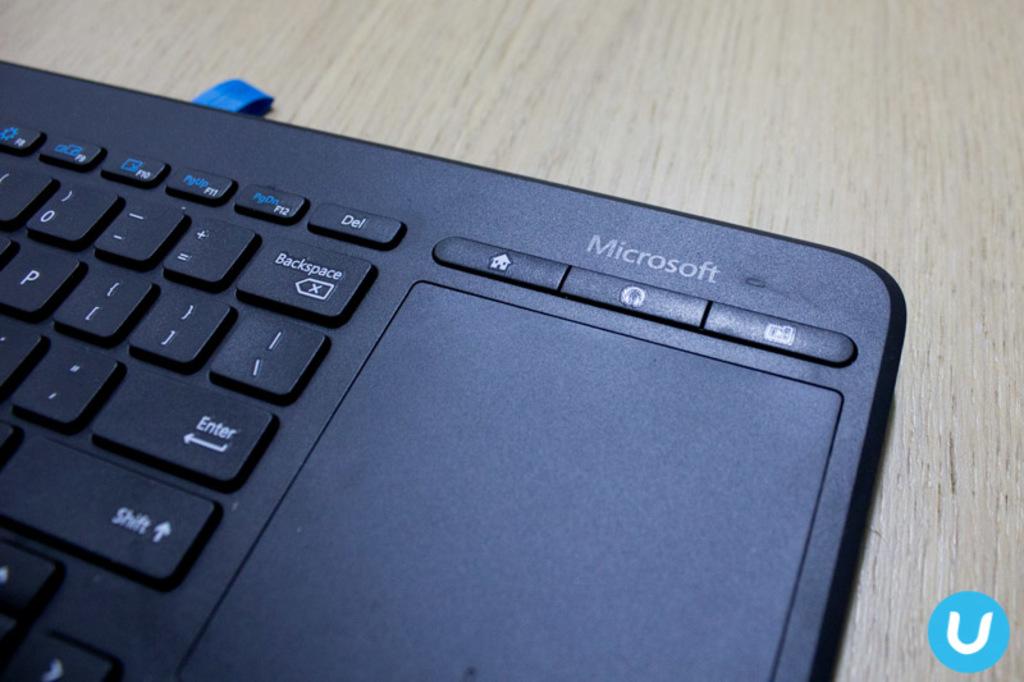What brand is the keyboard of?
Your response must be concise. Microsoft. What brand is the keyboard?
Keep it short and to the point. Microsoft. 